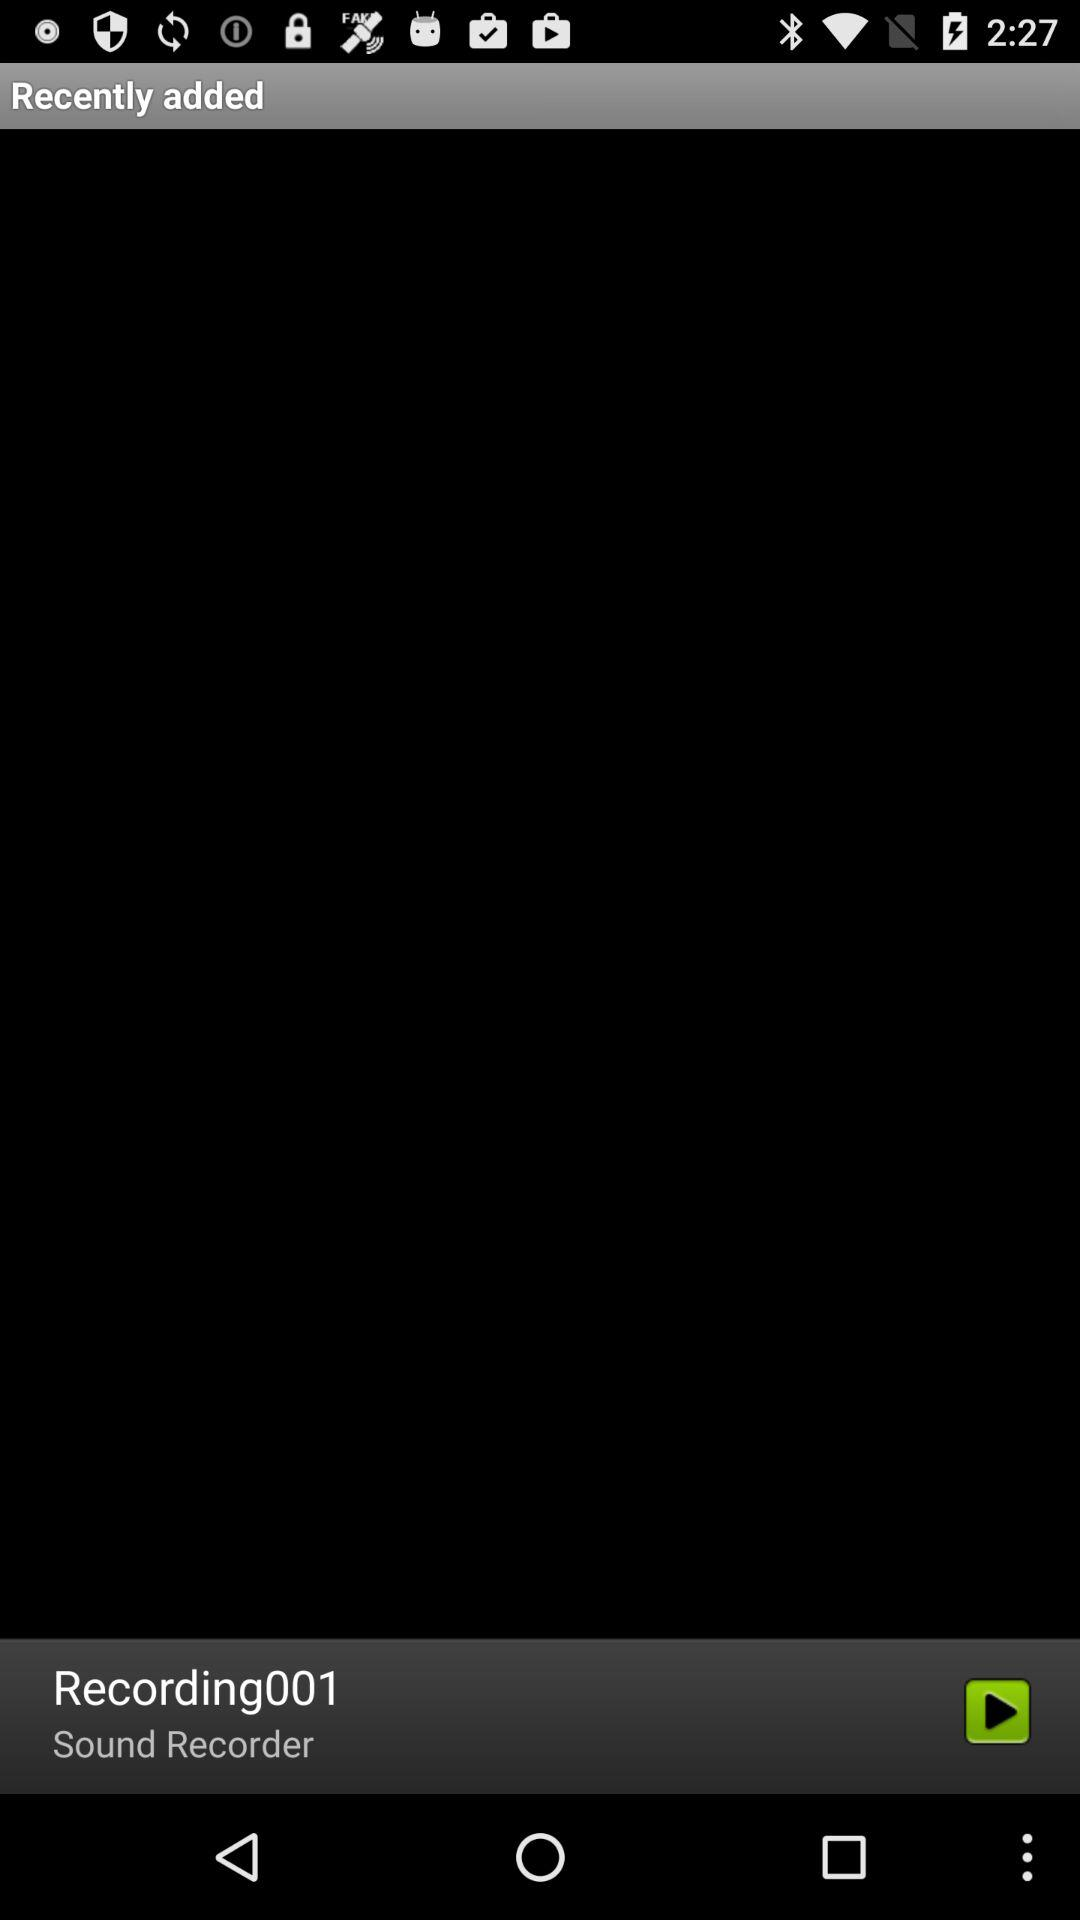How many recording files are there?
Answer the question using a single word or phrase. 1 